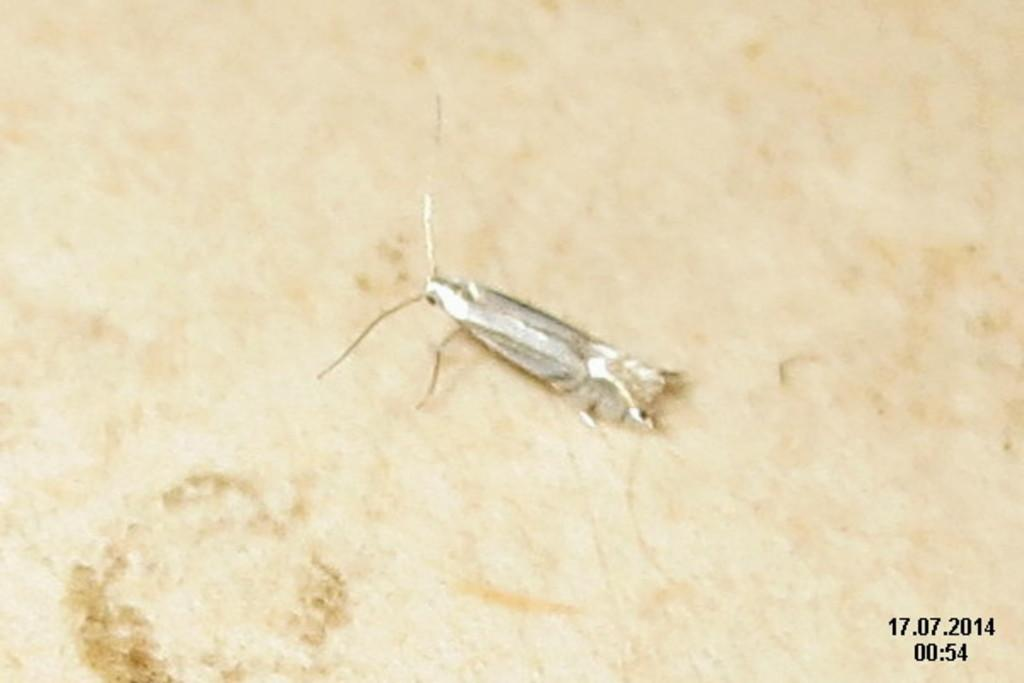What type of creature is in the image? There is an insect in the image. Where is the insect located? The insect is on a surface. What additional information can be found in the bottom right corner of the image? There are numbers in the bottom right corner of the image. What type of tail can be seen on the insect in the image? There is no tail visible on the insect in the image. Can you describe the shape of the insect's body in the image? The insect's body shape cannot be determined from the image alone, as it is not clear enough to discern specific features. 